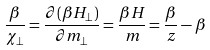<formula> <loc_0><loc_0><loc_500><loc_500>\frac { \beta } { \chi _ { \perp } } = \frac { \partial ( \beta H _ { \perp } ) } { \partial m _ { \perp } } = \frac { \beta H } { m } = \frac { \beta } { z } - \beta</formula> 